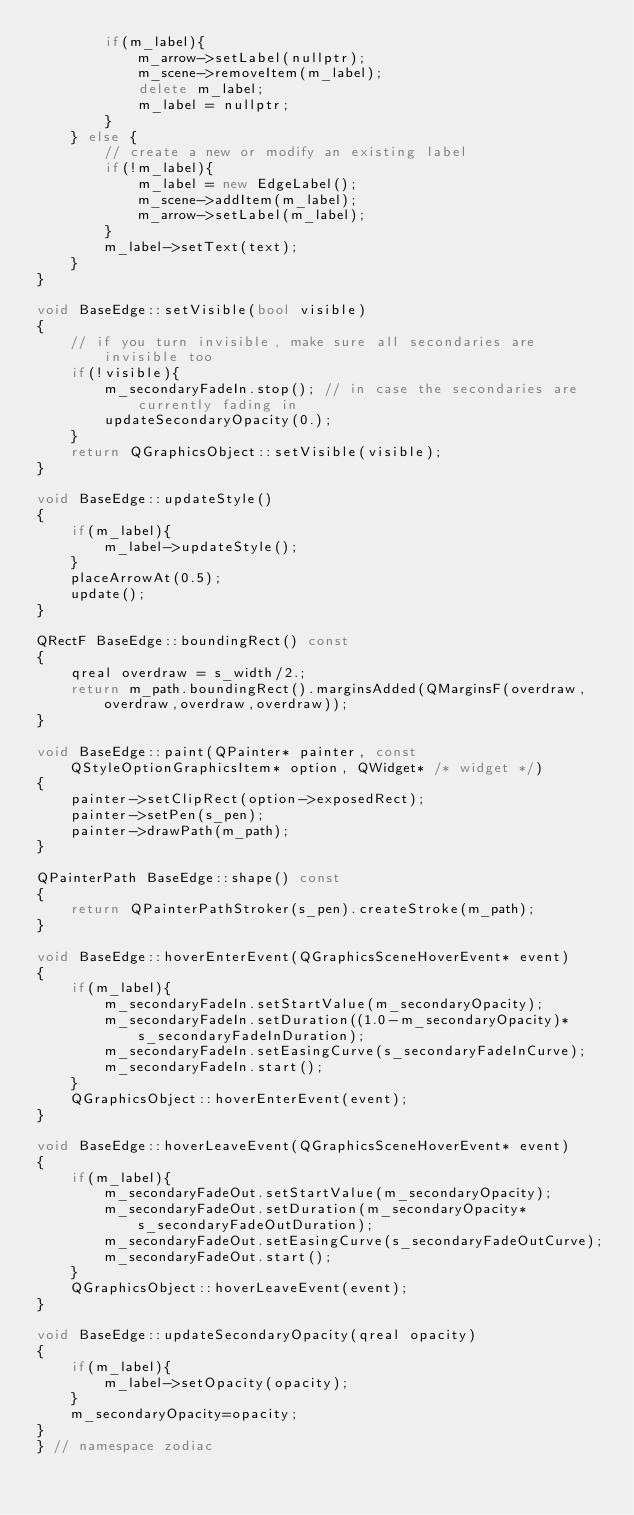Convert code to text. <code><loc_0><loc_0><loc_500><loc_500><_C++_>        if(m_label){
            m_arrow->setLabel(nullptr);
            m_scene->removeItem(m_label);
            delete m_label;
            m_label = nullptr;
        }
    } else {
        // create a new or modify an existing label
        if(!m_label){
            m_label = new EdgeLabel();
            m_scene->addItem(m_label);
            m_arrow->setLabel(m_label);
        }
        m_label->setText(text);
    }
}

void BaseEdge::setVisible(bool visible)
{
    // if you turn invisible, make sure all secondaries are invisible too
    if(!visible){
        m_secondaryFadeIn.stop(); // in case the secondaries are currently fading in
        updateSecondaryOpacity(0.);
    }
    return QGraphicsObject::setVisible(visible);
}

void BaseEdge::updateStyle()
{
    if(m_label){
        m_label->updateStyle();
    }
    placeArrowAt(0.5);
    update();
}

QRectF BaseEdge::boundingRect() const
{
    qreal overdraw = s_width/2.;
    return m_path.boundingRect().marginsAdded(QMarginsF(overdraw,overdraw,overdraw,overdraw));
}

void BaseEdge::paint(QPainter* painter, const QStyleOptionGraphicsItem* option, QWidget* /* widget */)
{
    painter->setClipRect(option->exposedRect);
    painter->setPen(s_pen);
    painter->drawPath(m_path);
}

QPainterPath BaseEdge::shape() const
{
    return QPainterPathStroker(s_pen).createStroke(m_path);
}

void BaseEdge::hoverEnterEvent(QGraphicsSceneHoverEvent* event)
{
    if(m_label){
        m_secondaryFadeIn.setStartValue(m_secondaryOpacity);
        m_secondaryFadeIn.setDuration((1.0-m_secondaryOpacity)*s_secondaryFadeInDuration);
        m_secondaryFadeIn.setEasingCurve(s_secondaryFadeInCurve);
        m_secondaryFadeIn.start();
    }
    QGraphicsObject::hoverEnterEvent(event);
}

void BaseEdge::hoverLeaveEvent(QGraphicsSceneHoverEvent* event)
{
    if(m_label){
        m_secondaryFadeOut.setStartValue(m_secondaryOpacity);
        m_secondaryFadeOut.setDuration(m_secondaryOpacity*s_secondaryFadeOutDuration);
        m_secondaryFadeOut.setEasingCurve(s_secondaryFadeOutCurve);
        m_secondaryFadeOut.start();
    }
    QGraphicsObject::hoverLeaveEvent(event);
}

void BaseEdge::updateSecondaryOpacity(qreal opacity)
{
    if(m_label){
        m_label->setOpacity(opacity);
    }
    m_secondaryOpacity=opacity;
}
} // namespace zodiac
</code> 